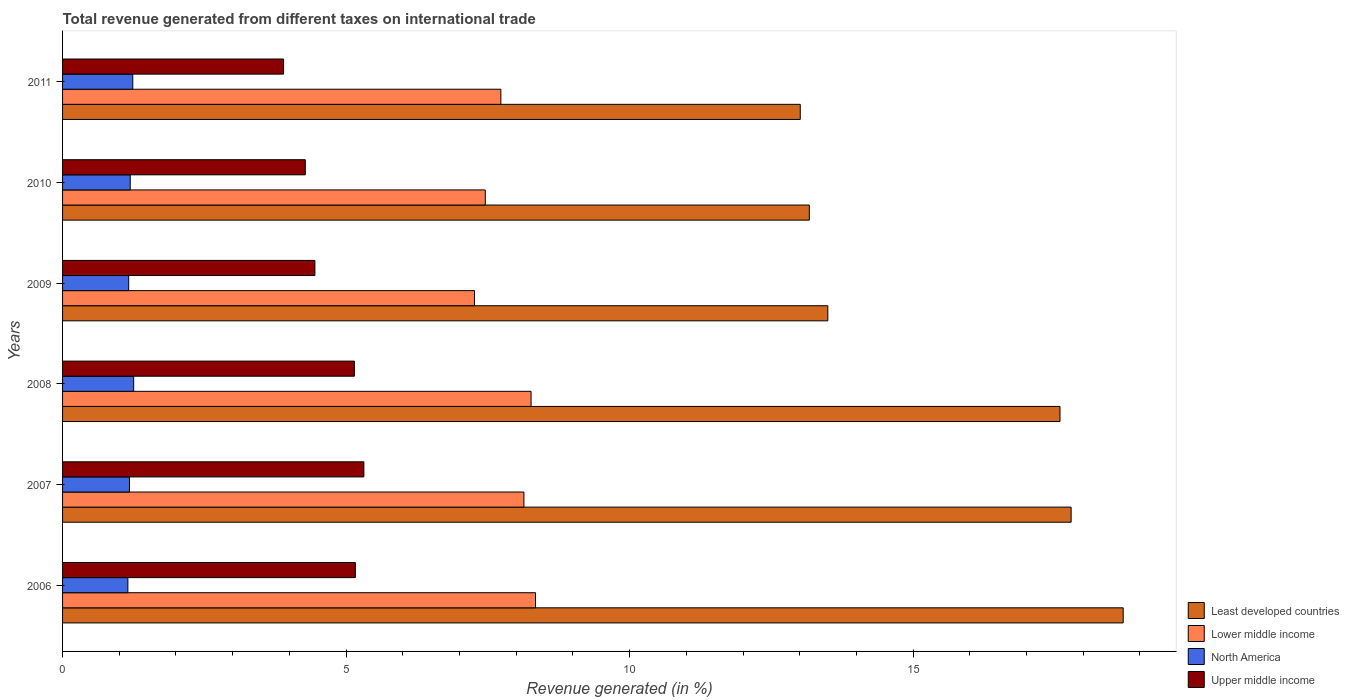How many groups of bars are there?
Make the answer very short. 6. Are the number of bars per tick equal to the number of legend labels?
Provide a succinct answer. Yes. How many bars are there on the 1st tick from the top?
Make the answer very short. 4. What is the total revenue generated in North America in 2011?
Provide a short and direct response. 1.24. Across all years, what is the maximum total revenue generated in Least developed countries?
Offer a terse response. 18.71. Across all years, what is the minimum total revenue generated in North America?
Make the answer very short. 1.15. In which year was the total revenue generated in Lower middle income minimum?
Keep it short and to the point. 2009. What is the total total revenue generated in North America in the graph?
Make the answer very short. 7.18. What is the difference between the total revenue generated in Upper middle income in 2007 and that in 2008?
Give a very brief answer. 0.17. What is the difference between the total revenue generated in Least developed countries in 2011 and the total revenue generated in North America in 2007?
Your answer should be compact. 11.83. What is the average total revenue generated in North America per year?
Make the answer very short. 1.2. In the year 2006, what is the difference between the total revenue generated in Upper middle income and total revenue generated in Lower middle income?
Give a very brief answer. -3.18. In how many years, is the total revenue generated in Lower middle income greater than 7 %?
Your answer should be compact. 6. What is the ratio of the total revenue generated in Lower middle income in 2008 to that in 2009?
Your answer should be very brief. 1.14. Is the difference between the total revenue generated in Upper middle income in 2009 and 2011 greater than the difference between the total revenue generated in Lower middle income in 2009 and 2011?
Offer a very short reply. Yes. What is the difference between the highest and the second highest total revenue generated in Least developed countries?
Keep it short and to the point. 0.92. What is the difference between the highest and the lowest total revenue generated in Upper middle income?
Your answer should be compact. 1.42. Is the sum of the total revenue generated in North America in 2008 and 2011 greater than the maximum total revenue generated in Lower middle income across all years?
Ensure brevity in your answer.  No. What does the 3rd bar from the top in 2009 represents?
Give a very brief answer. Lower middle income. What does the 4th bar from the bottom in 2008 represents?
Ensure brevity in your answer.  Upper middle income. How many bars are there?
Your response must be concise. 24. How many years are there in the graph?
Provide a short and direct response. 6. What is the difference between two consecutive major ticks on the X-axis?
Make the answer very short. 5. Does the graph contain any zero values?
Provide a succinct answer. No. How are the legend labels stacked?
Provide a succinct answer. Vertical. What is the title of the graph?
Make the answer very short. Total revenue generated from different taxes on international trade. What is the label or title of the X-axis?
Keep it short and to the point. Revenue generated (in %). What is the label or title of the Y-axis?
Your answer should be very brief. Years. What is the Revenue generated (in %) of Least developed countries in 2006?
Provide a succinct answer. 18.71. What is the Revenue generated (in %) in Lower middle income in 2006?
Offer a terse response. 8.34. What is the Revenue generated (in %) in North America in 2006?
Your answer should be very brief. 1.15. What is the Revenue generated (in %) of Upper middle income in 2006?
Ensure brevity in your answer.  5.16. What is the Revenue generated (in %) in Least developed countries in 2007?
Ensure brevity in your answer.  17.79. What is the Revenue generated (in %) in Lower middle income in 2007?
Give a very brief answer. 8.14. What is the Revenue generated (in %) of North America in 2007?
Your answer should be very brief. 1.18. What is the Revenue generated (in %) of Upper middle income in 2007?
Provide a succinct answer. 5.31. What is the Revenue generated (in %) of Least developed countries in 2008?
Offer a very short reply. 17.59. What is the Revenue generated (in %) in Lower middle income in 2008?
Provide a succinct answer. 8.26. What is the Revenue generated (in %) in North America in 2008?
Provide a short and direct response. 1.25. What is the Revenue generated (in %) of Upper middle income in 2008?
Your answer should be compact. 5.15. What is the Revenue generated (in %) in Least developed countries in 2009?
Offer a terse response. 13.5. What is the Revenue generated (in %) of Lower middle income in 2009?
Your answer should be compact. 7.26. What is the Revenue generated (in %) of North America in 2009?
Ensure brevity in your answer.  1.17. What is the Revenue generated (in %) of Upper middle income in 2009?
Your answer should be compact. 4.45. What is the Revenue generated (in %) in Least developed countries in 2010?
Keep it short and to the point. 13.17. What is the Revenue generated (in %) in Lower middle income in 2010?
Your answer should be compact. 7.45. What is the Revenue generated (in %) of North America in 2010?
Make the answer very short. 1.19. What is the Revenue generated (in %) in Upper middle income in 2010?
Keep it short and to the point. 4.28. What is the Revenue generated (in %) in Least developed countries in 2011?
Your answer should be compact. 13.01. What is the Revenue generated (in %) in Lower middle income in 2011?
Provide a short and direct response. 7.73. What is the Revenue generated (in %) of North America in 2011?
Your answer should be compact. 1.24. What is the Revenue generated (in %) in Upper middle income in 2011?
Make the answer very short. 3.9. Across all years, what is the maximum Revenue generated (in %) of Least developed countries?
Give a very brief answer. 18.71. Across all years, what is the maximum Revenue generated (in %) of Lower middle income?
Make the answer very short. 8.34. Across all years, what is the maximum Revenue generated (in %) of North America?
Give a very brief answer. 1.25. Across all years, what is the maximum Revenue generated (in %) of Upper middle income?
Keep it short and to the point. 5.31. Across all years, what is the minimum Revenue generated (in %) in Least developed countries?
Provide a short and direct response. 13.01. Across all years, what is the minimum Revenue generated (in %) of Lower middle income?
Offer a terse response. 7.26. Across all years, what is the minimum Revenue generated (in %) in North America?
Ensure brevity in your answer.  1.15. Across all years, what is the minimum Revenue generated (in %) in Upper middle income?
Your answer should be very brief. 3.9. What is the total Revenue generated (in %) in Least developed countries in the graph?
Your answer should be compact. 93.76. What is the total Revenue generated (in %) of Lower middle income in the graph?
Make the answer very short. 47.19. What is the total Revenue generated (in %) in North America in the graph?
Offer a very short reply. 7.18. What is the total Revenue generated (in %) of Upper middle income in the graph?
Your answer should be compact. 28.25. What is the difference between the Revenue generated (in %) of Least developed countries in 2006 and that in 2007?
Provide a succinct answer. 0.92. What is the difference between the Revenue generated (in %) in Lower middle income in 2006 and that in 2007?
Ensure brevity in your answer.  0.2. What is the difference between the Revenue generated (in %) of North America in 2006 and that in 2007?
Keep it short and to the point. -0.03. What is the difference between the Revenue generated (in %) in Least developed countries in 2006 and that in 2008?
Make the answer very short. 1.11. What is the difference between the Revenue generated (in %) of Lower middle income in 2006 and that in 2008?
Your answer should be compact. 0.08. What is the difference between the Revenue generated (in %) of North America in 2006 and that in 2008?
Keep it short and to the point. -0.1. What is the difference between the Revenue generated (in %) of Upper middle income in 2006 and that in 2008?
Give a very brief answer. 0.02. What is the difference between the Revenue generated (in %) of Least developed countries in 2006 and that in 2009?
Your response must be concise. 5.21. What is the difference between the Revenue generated (in %) in Lower middle income in 2006 and that in 2009?
Provide a succinct answer. 1.08. What is the difference between the Revenue generated (in %) of North America in 2006 and that in 2009?
Make the answer very short. -0.01. What is the difference between the Revenue generated (in %) in Upper middle income in 2006 and that in 2009?
Give a very brief answer. 0.71. What is the difference between the Revenue generated (in %) of Least developed countries in 2006 and that in 2010?
Offer a terse response. 5.54. What is the difference between the Revenue generated (in %) of Lower middle income in 2006 and that in 2010?
Provide a succinct answer. 0.89. What is the difference between the Revenue generated (in %) of North America in 2006 and that in 2010?
Give a very brief answer. -0.04. What is the difference between the Revenue generated (in %) of Upper middle income in 2006 and that in 2010?
Make the answer very short. 0.88. What is the difference between the Revenue generated (in %) in Least developed countries in 2006 and that in 2011?
Keep it short and to the point. 5.7. What is the difference between the Revenue generated (in %) of Lower middle income in 2006 and that in 2011?
Provide a short and direct response. 0.61. What is the difference between the Revenue generated (in %) in North America in 2006 and that in 2011?
Your response must be concise. -0.09. What is the difference between the Revenue generated (in %) in Upper middle income in 2006 and that in 2011?
Provide a succinct answer. 1.27. What is the difference between the Revenue generated (in %) of Least developed countries in 2007 and that in 2008?
Your answer should be compact. 0.2. What is the difference between the Revenue generated (in %) in Lower middle income in 2007 and that in 2008?
Your answer should be very brief. -0.13. What is the difference between the Revenue generated (in %) of North America in 2007 and that in 2008?
Provide a short and direct response. -0.07. What is the difference between the Revenue generated (in %) of Upper middle income in 2007 and that in 2008?
Provide a short and direct response. 0.17. What is the difference between the Revenue generated (in %) in Least developed countries in 2007 and that in 2009?
Give a very brief answer. 4.29. What is the difference between the Revenue generated (in %) of Lower middle income in 2007 and that in 2009?
Keep it short and to the point. 0.87. What is the difference between the Revenue generated (in %) in North America in 2007 and that in 2009?
Give a very brief answer. 0.01. What is the difference between the Revenue generated (in %) in Upper middle income in 2007 and that in 2009?
Provide a succinct answer. 0.86. What is the difference between the Revenue generated (in %) of Least developed countries in 2007 and that in 2010?
Provide a succinct answer. 4.62. What is the difference between the Revenue generated (in %) of Lower middle income in 2007 and that in 2010?
Provide a short and direct response. 0.68. What is the difference between the Revenue generated (in %) in North America in 2007 and that in 2010?
Offer a very short reply. -0.01. What is the difference between the Revenue generated (in %) in Upper middle income in 2007 and that in 2010?
Provide a short and direct response. 1.03. What is the difference between the Revenue generated (in %) of Least developed countries in 2007 and that in 2011?
Provide a short and direct response. 4.78. What is the difference between the Revenue generated (in %) in Lower middle income in 2007 and that in 2011?
Provide a short and direct response. 0.41. What is the difference between the Revenue generated (in %) in North America in 2007 and that in 2011?
Provide a succinct answer. -0.06. What is the difference between the Revenue generated (in %) in Upper middle income in 2007 and that in 2011?
Your answer should be compact. 1.42. What is the difference between the Revenue generated (in %) in Least developed countries in 2008 and that in 2009?
Your response must be concise. 4.09. What is the difference between the Revenue generated (in %) of Lower middle income in 2008 and that in 2009?
Your answer should be very brief. 1. What is the difference between the Revenue generated (in %) in North America in 2008 and that in 2009?
Make the answer very short. 0.09. What is the difference between the Revenue generated (in %) in Upper middle income in 2008 and that in 2009?
Provide a short and direct response. 0.7. What is the difference between the Revenue generated (in %) in Least developed countries in 2008 and that in 2010?
Offer a terse response. 4.42. What is the difference between the Revenue generated (in %) in Lower middle income in 2008 and that in 2010?
Offer a very short reply. 0.81. What is the difference between the Revenue generated (in %) of North America in 2008 and that in 2010?
Your answer should be very brief. 0.06. What is the difference between the Revenue generated (in %) in Upper middle income in 2008 and that in 2010?
Give a very brief answer. 0.87. What is the difference between the Revenue generated (in %) of Least developed countries in 2008 and that in 2011?
Your answer should be very brief. 4.58. What is the difference between the Revenue generated (in %) in Lower middle income in 2008 and that in 2011?
Ensure brevity in your answer.  0.53. What is the difference between the Revenue generated (in %) of North America in 2008 and that in 2011?
Ensure brevity in your answer.  0.02. What is the difference between the Revenue generated (in %) of Upper middle income in 2008 and that in 2011?
Make the answer very short. 1.25. What is the difference between the Revenue generated (in %) in Least developed countries in 2009 and that in 2010?
Your answer should be compact. 0.33. What is the difference between the Revenue generated (in %) of Lower middle income in 2009 and that in 2010?
Keep it short and to the point. -0.19. What is the difference between the Revenue generated (in %) of North America in 2009 and that in 2010?
Your answer should be compact. -0.03. What is the difference between the Revenue generated (in %) of Upper middle income in 2009 and that in 2010?
Offer a terse response. 0.17. What is the difference between the Revenue generated (in %) of Least developed countries in 2009 and that in 2011?
Provide a succinct answer. 0.49. What is the difference between the Revenue generated (in %) in Lower middle income in 2009 and that in 2011?
Provide a short and direct response. -0.47. What is the difference between the Revenue generated (in %) of North America in 2009 and that in 2011?
Keep it short and to the point. -0.07. What is the difference between the Revenue generated (in %) in Upper middle income in 2009 and that in 2011?
Provide a succinct answer. 0.55. What is the difference between the Revenue generated (in %) in Least developed countries in 2010 and that in 2011?
Provide a succinct answer. 0.16. What is the difference between the Revenue generated (in %) in Lower middle income in 2010 and that in 2011?
Your response must be concise. -0.27. What is the difference between the Revenue generated (in %) in North America in 2010 and that in 2011?
Give a very brief answer. -0.04. What is the difference between the Revenue generated (in %) in Upper middle income in 2010 and that in 2011?
Offer a very short reply. 0.38. What is the difference between the Revenue generated (in %) of Least developed countries in 2006 and the Revenue generated (in %) of Lower middle income in 2007?
Provide a short and direct response. 10.57. What is the difference between the Revenue generated (in %) of Least developed countries in 2006 and the Revenue generated (in %) of North America in 2007?
Your response must be concise. 17.53. What is the difference between the Revenue generated (in %) in Least developed countries in 2006 and the Revenue generated (in %) in Upper middle income in 2007?
Offer a terse response. 13.39. What is the difference between the Revenue generated (in %) in Lower middle income in 2006 and the Revenue generated (in %) in North America in 2007?
Offer a very short reply. 7.16. What is the difference between the Revenue generated (in %) of Lower middle income in 2006 and the Revenue generated (in %) of Upper middle income in 2007?
Provide a succinct answer. 3.03. What is the difference between the Revenue generated (in %) in North America in 2006 and the Revenue generated (in %) in Upper middle income in 2007?
Your answer should be very brief. -4.16. What is the difference between the Revenue generated (in %) in Least developed countries in 2006 and the Revenue generated (in %) in Lower middle income in 2008?
Ensure brevity in your answer.  10.44. What is the difference between the Revenue generated (in %) of Least developed countries in 2006 and the Revenue generated (in %) of North America in 2008?
Your answer should be very brief. 17.45. What is the difference between the Revenue generated (in %) in Least developed countries in 2006 and the Revenue generated (in %) in Upper middle income in 2008?
Your response must be concise. 13.56. What is the difference between the Revenue generated (in %) in Lower middle income in 2006 and the Revenue generated (in %) in North America in 2008?
Your answer should be very brief. 7.09. What is the difference between the Revenue generated (in %) in Lower middle income in 2006 and the Revenue generated (in %) in Upper middle income in 2008?
Provide a succinct answer. 3.19. What is the difference between the Revenue generated (in %) in North America in 2006 and the Revenue generated (in %) in Upper middle income in 2008?
Provide a succinct answer. -3.99. What is the difference between the Revenue generated (in %) of Least developed countries in 2006 and the Revenue generated (in %) of Lower middle income in 2009?
Give a very brief answer. 11.44. What is the difference between the Revenue generated (in %) of Least developed countries in 2006 and the Revenue generated (in %) of North America in 2009?
Provide a short and direct response. 17.54. What is the difference between the Revenue generated (in %) in Least developed countries in 2006 and the Revenue generated (in %) in Upper middle income in 2009?
Ensure brevity in your answer.  14.26. What is the difference between the Revenue generated (in %) in Lower middle income in 2006 and the Revenue generated (in %) in North America in 2009?
Your answer should be compact. 7.18. What is the difference between the Revenue generated (in %) in Lower middle income in 2006 and the Revenue generated (in %) in Upper middle income in 2009?
Give a very brief answer. 3.89. What is the difference between the Revenue generated (in %) of North America in 2006 and the Revenue generated (in %) of Upper middle income in 2009?
Make the answer very short. -3.3. What is the difference between the Revenue generated (in %) in Least developed countries in 2006 and the Revenue generated (in %) in Lower middle income in 2010?
Your answer should be very brief. 11.25. What is the difference between the Revenue generated (in %) of Least developed countries in 2006 and the Revenue generated (in %) of North America in 2010?
Your answer should be very brief. 17.51. What is the difference between the Revenue generated (in %) of Least developed countries in 2006 and the Revenue generated (in %) of Upper middle income in 2010?
Provide a succinct answer. 14.42. What is the difference between the Revenue generated (in %) of Lower middle income in 2006 and the Revenue generated (in %) of North America in 2010?
Provide a succinct answer. 7.15. What is the difference between the Revenue generated (in %) of Lower middle income in 2006 and the Revenue generated (in %) of Upper middle income in 2010?
Offer a very short reply. 4.06. What is the difference between the Revenue generated (in %) of North America in 2006 and the Revenue generated (in %) of Upper middle income in 2010?
Your answer should be compact. -3.13. What is the difference between the Revenue generated (in %) of Least developed countries in 2006 and the Revenue generated (in %) of Lower middle income in 2011?
Offer a very short reply. 10.98. What is the difference between the Revenue generated (in %) in Least developed countries in 2006 and the Revenue generated (in %) in North America in 2011?
Ensure brevity in your answer.  17.47. What is the difference between the Revenue generated (in %) of Least developed countries in 2006 and the Revenue generated (in %) of Upper middle income in 2011?
Offer a very short reply. 14.81. What is the difference between the Revenue generated (in %) in Lower middle income in 2006 and the Revenue generated (in %) in North America in 2011?
Offer a very short reply. 7.1. What is the difference between the Revenue generated (in %) in Lower middle income in 2006 and the Revenue generated (in %) in Upper middle income in 2011?
Provide a short and direct response. 4.44. What is the difference between the Revenue generated (in %) of North America in 2006 and the Revenue generated (in %) of Upper middle income in 2011?
Provide a short and direct response. -2.75. What is the difference between the Revenue generated (in %) in Least developed countries in 2007 and the Revenue generated (in %) in Lower middle income in 2008?
Your answer should be compact. 9.52. What is the difference between the Revenue generated (in %) in Least developed countries in 2007 and the Revenue generated (in %) in North America in 2008?
Give a very brief answer. 16.53. What is the difference between the Revenue generated (in %) in Least developed countries in 2007 and the Revenue generated (in %) in Upper middle income in 2008?
Ensure brevity in your answer.  12.64. What is the difference between the Revenue generated (in %) in Lower middle income in 2007 and the Revenue generated (in %) in North America in 2008?
Your answer should be very brief. 6.88. What is the difference between the Revenue generated (in %) of Lower middle income in 2007 and the Revenue generated (in %) of Upper middle income in 2008?
Provide a short and direct response. 2.99. What is the difference between the Revenue generated (in %) of North America in 2007 and the Revenue generated (in %) of Upper middle income in 2008?
Keep it short and to the point. -3.97. What is the difference between the Revenue generated (in %) of Least developed countries in 2007 and the Revenue generated (in %) of Lower middle income in 2009?
Your answer should be compact. 10.52. What is the difference between the Revenue generated (in %) of Least developed countries in 2007 and the Revenue generated (in %) of North America in 2009?
Offer a very short reply. 16.62. What is the difference between the Revenue generated (in %) in Least developed countries in 2007 and the Revenue generated (in %) in Upper middle income in 2009?
Offer a very short reply. 13.34. What is the difference between the Revenue generated (in %) of Lower middle income in 2007 and the Revenue generated (in %) of North America in 2009?
Provide a short and direct response. 6.97. What is the difference between the Revenue generated (in %) in Lower middle income in 2007 and the Revenue generated (in %) in Upper middle income in 2009?
Provide a short and direct response. 3.69. What is the difference between the Revenue generated (in %) of North America in 2007 and the Revenue generated (in %) of Upper middle income in 2009?
Make the answer very short. -3.27. What is the difference between the Revenue generated (in %) in Least developed countries in 2007 and the Revenue generated (in %) in Lower middle income in 2010?
Your answer should be very brief. 10.33. What is the difference between the Revenue generated (in %) of Least developed countries in 2007 and the Revenue generated (in %) of North America in 2010?
Your answer should be very brief. 16.59. What is the difference between the Revenue generated (in %) of Least developed countries in 2007 and the Revenue generated (in %) of Upper middle income in 2010?
Offer a very short reply. 13.51. What is the difference between the Revenue generated (in %) of Lower middle income in 2007 and the Revenue generated (in %) of North America in 2010?
Your answer should be very brief. 6.94. What is the difference between the Revenue generated (in %) of Lower middle income in 2007 and the Revenue generated (in %) of Upper middle income in 2010?
Give a very brief answer. 3.86. What is the difference between the Revenue generated (in %) of North America in 2007 and the Revenue generated (in %) of Upper middle income in 2010?
Make the answer very short. -3.1. What is the difference between the Revenue generated (in %) in Least developed countries in 2007 and the Revenue generated (in %) in Lower middle income in 2011?
Ensure brevity in your answer.  10.06. What is the difference between the Revenue generated (in %) in Least developed countries in 2007 and the Revenue generated (in %) in North America in 2011?
Offer a very short reply. 16.55. What is the difference between the Revenue generated (in %) in Least developed countries in 2007 and the Revenue generated (in %) in Upper middle income in 2011?
Your answer should be compact. 13.89. What is the difference between the Revenue generated (in %) of Lower middle income in 2007 and the Revenue generated (in %) of North America in 2011?
Offer a terse response. 6.9. What is the difference between the Revenue generated (in %) in Lower middle income in 2007 and the Revenue generated (in %) in Upper middle income in 2011?
Offer a terse response. 4.24. What is the difference between the Revenue generated (in %) in North America in 2007 and the Revenue generated (in %) in Upper middle income in 2011?
Your response must be concise. -2.72. What is the difference between the Revenue generated (in %) in Least developed countries in 2008 and the Revenue generated (in %) in Lower middle income in 2009?
Offer a very short reply. 10.33. What is the difference between the Revenue generated (in %) in Least developed countries in 2008 and the Revenue generated (in %) in North America in 2009?
Keep it short and to the point. 16.43. What is the difference between the Revenue generated (in %) of Least developed countries in 2008 and the Revenue generated (in %) of Upper middle income in 2009?
Give a very brief answer. 13.14. What is the difference between the Revenue generated (in %) in Lower middle income in 2008 and the Revenue generated (in %) in North America in 2009?
Your response must be concise. 7.1. What is the difference between the Revenue generated (in %) of Lower middle income in 2008 and the Revenue generated (in %) of Upper middle income in 2009?
Your answer should be very brief. 3.81. What is the difference between the Revenue generated (in %) of North America in 2008 and the Revenue generated (in %) of Upper middle income in 2009?
Make the answer very short. -3.2. What is the difference between the Revenue generated (in %) of Least developed countries in 2008 and the Revenue generated (in %) of Lower middle income in 2010?
Keep it short and to the point. 10.14. What is the difference between the Revenue generated (in %) of Least developed countries in 2008 and the Revenue generated (in %) of North America in 2010?
Give a very brief answer. 16.4. What is the difference between the Revenue generated (in %) of Least developed countries in 2008 and the Revenue generated (in %) of Upper middle income in 2010?
Provide a short and direct response. 13.31. What is the difference between the Revenue generated (in %) of Lower middle income in 2008 and the Revenue generated (in %) of North America in 2010?
Give a very brief answer. 7.07. What is the difference between the Revenue generated (in %) in Lower middle income in 2008 and the Revenue generated (in %) in Upper middle income in 2010?
Your response must be concise. 3.98. What is the difference between the Revenue generated (in %) of North America in 2008 and the Revenue generated (in %) of Upper middle income in 2010?
Your answer should be very brief. -3.03. What is the difference between the Revenue generated (in %) in Least developed countries in 2008 and the Revenue generated (in %) in Lower middle income in 2011?
Provide a succinct answer. 9.86. What is the difference between the Revenue generated (in %) in Least developed countries in 2008 and the Revenue generated (in %) in North America in 2011?
Make the answer very short. 16.35. What is the difference between the Revenue generated (in %) in Least developed countries in 2008 and the Revenue generated (in %) in Upper middle income in 2011?
Your answer should be very brief. 13.69. What is the difference between the Revenue generated (in %) of Lower middle income in 2008 and the Revenue generated (in %) of North America in 2011?
Ensure brevity in your answer.  7.02. What is the difference between the Revenue generated (in %) in Lower middle income in 2008 and the Revenue generated (in %) in Upper middle income in 2011?
Offer a very short reply. 4.36. What is the difference between the Revenue generated (in %) of North America in 2008 and the Revenue generated (in %) of Upper middle income in 2011?
Provide a succinct answer. -2.64. What is the difference between the Revenue generated (in %) in Least developed countries in 2009 and the Revenue generated (in %) in Lower middle income in 2010?
Keep it short and to the point. 6.04. What is the difference between the Revenue generated (in %) in Least developed countries in 2009 and the Revenue generated (in %) in North America in 2010?
Keep it short and to the point. 12.3. What is the difference between the Revenue generated (in %) in Least developed countries in 2009 and the Revenue generated (in %) in Upper middle income in 2010?
Keep it short and to the point. 9.21. What is the difference between the Revenue generated (in %) in Lower middle income in 2009 and the Revenue generated (in %) in North America in 2010?
Provide a short and direct response. 6.07. What is the difference between the Revenue generated (in %) of Lower middle income in 2009 and the Revenue generated (in %) of Upper middle income in 2010?
Keep it short and to the point. 2.98. What is the difference between the Revenue generated (in %) in North America in 2009 and the Revenue generated (in %) in Upper middle income in 2010?
Provide a succinct answer. -3.12. What is the difference between the Revenue generated (in %) in Least developed countries in 2009 and the Revenue generated (in %) in Lower middle income in 2011?
Keep it short and to the point. 5.77. What is the difference between the Revenue generated (in %) of Least developed countries in 2009 and the Revenue generated (in %) of North America in 2011?
Your answer should be compact. 12.26. What is the difference between the Revenue generated (in %) of Least developed countries in 2009 and the Revenue generated (in %) of Upper middle income in 2011?
Make the answer very short. 9.6. What is the difference between the Revenue generated (in %) in Lower middle income in 2009 and the Revenue generated (in %) in North America in 2011?
Your response must be concise. 6.03. What is the difference between the Revenue generated (in %) in Lower middle income in 2009 and the Revenue generated (in %) in Upper middle income in 2011?
Offer a terse response. 3.37. What is the difference between the Revenue generated (in %) in North America in 2009 and the Revenue generated (in %) in Upper middle income in 2011?
Give a very brief answer. -2.73. What is the difference between the Revenue generated (in %) in Least developed countries in 2010 and the Revenue generated (in %) in Lower middle income in 2011?
Your answer should be very brief. 5.44. What is the difference between the Revenue generated (in %) in Least developed countries in 2010 and the Revenue generated (in %) in North America in 2011?
Offer a very short reply. 11.93. What is the difference between the Revenue generated (in %) in Least developed countries in 2010 and the Revenue generated (in %) in Upper middle income in 2011?
Give a very brief answer. 9.27. What is the difference between the Revenue generated (in %) in Lower middle income in 2010 and the Revenue generated (in %) in North America in 2011?
Your answer should be compact. 6.22. What is the difference between the Revenue generated (in %) in Lower middle income in 2010 and the Revenue generated (in %) in Upper middle income in 2011?
Keep it short and to the point. 3.56. What is the difference between the Revenue generated (in %) of North America in 2010 and the Revenue generated (in %) of Upper middle income in 2011?
Offer a very short reply. -2.7. What is the average Revenue generated (in %) of Least developed countries per year?
Ensure brevity in your answer.  15.63. What is the average Revenue generated (in %) in Lower middle income per year?
Make the answer very short. 7.86. What is the average Revenue generated (in %) of North America per year?
Provide a short and direct response. 1.2. What is the average Revenue generated (in %) of Upper middle income per year?
Your answer should be very brief. 4.71. In the year 2006, what is the difference between the Revenue generated (in %) of Least developed countries and Revenue generated (in %) of Lower middle income?
Provide a short and direct response. 10.36. In the year 2006, what is the difference between the Revenue generated (in %) in Least developed countries and Revenue generated (in %) in North America?
Your answer should be compact. 17.55. In the year 2006, what is the difference between the Revenue generated (in %) in Least developed countries and Revenue generated (in %) in Upper middle income?
Give a very brief answer. 13.54. In the year 2006, what is the difference between the Revenue generated (in %) of Lower middle income and Revenue generated (in %) of North America?
Offer a terse response. 7.19. In the year 2006, what is the difference between the Revenue generated (in %) in Lower middle income and Revenue generated (in %) in Upper middle income?
Offer a terse response. 3.18. In the year 2006, what is the difference between the Revenue generated (in %) of North America and Revenue generated (in %) of Upper middle income?
Provide a succinct answer. -4.01. In the year 2007, what is the difference between the Revenue generated (in %) in Least developed countries and Revenue generated (in %) in Lower middle income?
Your answer should be very brief. 9.65. In the year 2007, what is the difference between the Revenue generated (in %) of Least developed countries and Revenue generated (in %) of North America?
Provide a short and direct response. 16.61. In the year 2007, what is the difference between the Revenue generated (in %) of Least developed countries and Revenue generated (in %) of Upper middle income?
Provide a short and direct response. 12.47. In the year 2007, what is the difference between the Revenue generated (in %) in Lower middle income and Revenue generated (in %) in North America?
Provide a succinct answer. 6.96. In the year 2007, what is the difference between the Revenue generated (in %) in Lower middle income and Revenue generated (in %) in Upper middle income?
Make the answer very short. 2.82. In the year 2007, what is the difference between the Revenue generated (in %) of North America and Revenue generated (in %) of Upper middle income?
Provide a short and direct response. -4.13. In the year 2008, what is the difference between the Revenue generated (in %) in Least developed countries and Revenue generated (in %) in Lower middle income?
Ensure brevity in your answer.  9.33. In the year 2008, what is the difference between the Revenue generated (in %) of Least developed countries and Revenue generated (in %) of North America?
Offer a terse response. 16.34. In the year 2008, what is the difference between the Revenue generated (in %) of Least developed countries and Revenue generated (in %) of Upper middle income?
Make the answer very short. 12.44. In the year 2008, what is the difference between the Revenue generated (in %) in Lower middle income and Revenue generated (in %) in North America?
Offer a very short reply. 7.01. In the year 2008, what is the difference between the Revenue generated (in %) of Lower middle income and Revenue generated (in %) of Upper middle income?
Give a very brief answer. 3.12. In the year 2008, what is the difference between the Revenue generated (in %) of North America and Revenue generated (in %) of Upper middle income?
Ensure brevity in your answer.  -3.89. In the year 2009, what is the difference between the Revenue generated (in %) of Least developed countries and Revenue generated (in %) of Lower middle income?
Offer a very short reply. 6.23. In the year 2009, what is the difference between the Revenue generated (in %) of Least developed countries and Revenue generated (in %) of North America?
Ensure brevity in your answer.  12.33. In the year 2009, what is the difference between the Revenue generated (in %) in Least developed countries and Revenue generated (in %) in Upper middle income?
Ensure brevity in your answer.  9.05. In the year 2009, what is the difference between the Revenue generated (in %) of Lower middle income and Revenue generated (in %) of North America?
Give a very brief answer. 6.1. In the year 2009, what is the difference between the Revenue generated (in %) in Lower middle income and Revenue generated (in %) in Upper middle income?
Provide a succinct answer. 2.81. In the year 2009, what is the difference between the Revenue generated (in %) in North America and Revenue generated (in %) in Upper middle income?
Provide a short and direct response. -3.28. In the year 2010, what is the difference between the Revenue generated (in %) in Least developed countries and Revenue generated (in %) in Lower middle income?
Provide a short and direct response. 5.71. In the year 2010, what is the difference between the Revenue generated (in %) in Least developed countries and Revenue generated (in %) in North America?
Give a very brief answer. 11.98. In the year 2010, what is the difference between the Revenue generated (in %) of Least developed countries and Revenue generated (in %) of Upper middle income?
Ensure brevity in your answer.  8.89. In the year 2010, what is the difference between the Revenue generated (in %) in Lower middle income and Revenue generated (in %) in North America?
Provide a short and direct response. 6.26. In the year 2010, what is the difference between the Revenue generated (in %) in Lower middle income and Revenue generated (in %) in Upper middle income?
Keep it short and to the point. 3.17. In the year 2010, what is the difference between the Revenue generated (in %) of North America and Revenue generated (in %) of Upper middle income?
Your response must be concise. -3.09. In the year 2011, what is the difference between the Revenue generated (in %) of Least developed countries and Revenue generated (in %) of Lower middle income?
Provide a succinct answer. 5.28. In the year 2011, what is the difference between the Revenue generated (in %) of Least developed countries and Revenue generated (in %) of North America?
Offer a terse response. 11.77. In the year 2011, what is the difference between the Revenue generated (in %) in Least developed countries and Revenue generated (in %) in Upper middle income?
Provide a succinct answer. 9.11. In the year 2011, what is the difference between the Revenue generated (in %) of Lower middle income and Revenue generated (in %) of North America?
Your response must be concise. 6.49. In the year 2011, what is the difference between the Revenue generated (in %) in Lower middle income and Revenue generated (in %) in Upper middle income?
Offer a terse response. 3.83. In the year 2011, what is the difference between the Revenue generated (in %) of North America and Revenue generated (in %) of Upper middle income?
Your answer should be very brief. -2.66. What is the ratio of the Revenue generated (in %) in Least developed countries in 2006 to that in 2007?
Make the answer very short. 1.05. What is the ratio of the Revenue generated (in %) in Lower middle income in 2006 to that in 2007?
Your response must be concise. 1.03. What is the ratio of the Revenue generated (in %) in North America in 2006 to that in 2007?
Your answer should be very brief. 0.98. What is the ratio of the Revenue generated (in %) in Upper middle income in 2006 to that in 2007?
Give a very brief answer. 0.97. What is the ratio of the Revenue generated (in %) of Least developed countries in 2006 to that in 2008?
Give a very brief answer. 1.06. What is the ratio of the Revenue generated (in %) of Lower middle income in 2006 to that in 2008?
Keep it short and to the point. 1.01. What is the ratio of the Revenue generated (in %) in North America in 2006 to that in 2008?
Provide a succinct answer. 0.92. What is the ratio of the Revenue generated (in %) in Upper middle income in 2006 to that in 2008?
Your answer should be compact. 1. What is the ratio of the Revenue generated (in %) in Least developed countries in 2006 to that in 2009?
Provide a succinct answer. 1.39. What is the ratio of the Revenue generated (in %) of Lower middle income in 2006 to that in 2009?
Offer a very short reply. 1.15. What is the ratio of the Revenue generated (in %) of North America in 2006 to that in 2009?
Keep it short and to the point. 0.99. What is the ratio of the Revenue generated (in %) of Upper middle income in 2006 to that in 2009?
Your answer should be compact. 1.16. What is the ratio of the Revenue generated (in %) of Least developed countries in 2006 to that in 2010?
Keep it short and to the point. 1.42. What is the ratio of the Revenue generated (in %) of Lower middle income in 2006 to that in 2010?
Your answer should be compact. 1.12. What is the ratio of the Revenue generated (in %) in North America in 2006 to that in 2010?
Give a very brief answer. 0.97. What is the ratio of the Revenue generated (in %) in Upper middle income in 2006 to that in 2010?
Ensure brevity in your answer.  1.21. What is the ratio of the Revenue generated (in %) of Least developed countries in 2006 to that in 2011?
Offer a terse response. 1.44. What is the ratio of the Revenue generated (in %) in Lower middle income in 2006 to that in 2011?
Ensure brevity in your answer.  1.08. What is the ratio of the Revenue generated (in %) in North America in 2006 to that in 2011?
Offer a very short reply. 0.93. What is the ratio of the Revenue generated (in %) in Upper middle income in 2006 to that in 2011?
Your answer should be compact. 1.32. What is the ratio of the Revenue generated (in %) in Least developed countries in 2007 to that in 2008?
Provide a short and direct response. 1.01. What is the ratio of the Revenue generated (in %) of Lower middle income in 2007 to that in 2008?
Your answer should be compact. 0.98. What is the ratio of the Revenue generated (in %) in North America in 2007 to that in 2008?
Ensure brevity in your answer.  0.94. What is the ratio of the Revenue generated (in %) in Upper middle income in 2007 to that in 2008?
Your answer should be very brief. 1.03. What is the ratio of the Revenue generated (in %) of Least developed countries in 2007 to that in 2009?
Provide a short and direct response. 1.32. What is the ratio of the Revenue generated (in %) of Lower middle income in 2007 to that in 2009?
Give a very brief answer. 1.12. What is the ratio of the Revenue generated (in %) in North America in 2007 to that in 2009?
Provide a succinct answer. 1.01. What is the ratio of the Revenue generated (in %) in Upper middle income in 2007 to that in 2009?
Provide a succinct answer. 1.19. What is the ratio of the Revenue generated (in %) of Least developed countries in 2007 to that in 2010?
Your response must be concise. 1.35. What is the ratio of the Revenue generated (in %) in Lower middle income in 2007 to that in 2010?
Offer a terse response. 1.09. What is the ratio of the Revenue generated (in %) in Upper middle income in 2007 to that in 2010?
Offer a terse response. 1.24. What is the ratio of the Revenue generated (in %) in Least developed countries in 2007 to that in 2011?
Provide a succinct answer. 1.37. What is the ratio of the Revenue generated (in %) in Lower middle income in 2007 to that in 2011?
Provide a succinct answer. 1.05. What is the ratio of the Revenue generated (in %) of North America in 2007 to that in 2011?
Your answer should be very brief. 0.95. What is the ratio of the Revenue generated (in %) in Upper middle income in 2007 to that in 2011?
Ensure brevity in your answer.  1.36. What is the ratio of the Revenue generated (in %) in Least developed countries in 2008 to that in 2009?
Your response must be concise. 1.3. What is the ratio of the Revenue generated (in %) in Lower middle income in 2008 to that in 2009?
Provide a short and direct response. 1.14. What is the ratio of the Revenue generated (in %) in North America in 2008 to that in 2009?
Provide a succinct answer. 1.08. What is the ratio of the Revenue generated (in %) in Upper middle income in 2008 to that in 2009?
Ensure brevity in your answer.  1.16. What is the ratio of the Revenue generated (in %) of Least developed countries in 2008 to that in 2010?
Make the answer very short. 1.34. What is the ratio of the Revenue generated (in %) in Lower middle income in 2008 to that in 2010?
Your answer should be compact. 1.11. What is the ratio of the Revenue generated (in %) in North America in 2008 to that in 2010?
Keep it short and to the point. 1.05. What is the ratio of the Revenue generated (in %) in Upper middle income in 2008 to that in 2010?
Offer a very short reply. 1.2. What is the ratio of the Revenue generated (in %) of Least developed countries in 2008 to that in 2011?
Ensure brevity in your answer.  1.35. What is the ratio of the Revenue generated (in %) in Lower middle income in 2008 to that in 2011?
Your answer should be compact. 1.07. What is the ratio of the Revenue generated (in %) of North America in 2008 to that in 2011?
Provide a short and direct response. 1.01. What is the ratio of the Revenue generated (in %) in Upper middle income in 2008 to that in 2011?
Your answer should be very brief. 1.32. What is the ratio of the Revenue generated (in %) of Least developed countries in 2009 to that in 2010?
Provide a succinct answer. 1.02. What is the ratio of the Revenue generated (in %) of Lower middle income in 2009 to that in 2010?
Your answer should be very brief. 0.97. What is the ratio of the Revenue generated (in %) in North America in 2009 to that in 2010?
Ensure brevity in your answer.  0.98. What is the ratio of the Revenue generated (in %) in Upper middle income in 2009 to that in 2010?
Provide a short and direct response. 1.04. What is the ratio of the Revenue generated (in %) in Least developed countries in 2009 to that in 2011?
Keep it short and to the point. 1.04. What is the ratio of the Revenue generated (in %) of Lower middle income in 2009 to that in 2011?
Your answer should be compact. 0.94. What is the ratio of the Revenue generated (in %) of North America in 2009 to that in 2011?
Offer a terse response. 0.94. What is the ratio of the Revenue generated (in %) in Upper middle income in 2009 to that in 2011?
Your answer should be compact. 1.14. What is the ratio of the Revenue generated (in %) in Least developed countries in 2010 to that in 2011?
Make the answer very short. 1.01. What is the ratio of the Revenue generated (in %) of Lower middle income in 2010 to that in 2011?
Offer a terse response. 0.96. What is the ratio of the Revenue generated (in %) of North America in 2010 to that in 2011?
Your answer should be very brief. 0.96. What is the ratio of the Revenue generated (in %) in Upper middle income in 2010 to that in 2011?
Provide a succinct answer. 1.1. What is the difference between the highest and the second highest Revenue generated (in %) in Least developed countries?
Your answer should be very brief. 0.92. What is the difference between the highest and the second highest Revenue generated (in %) in Lower middle income?
Your response must be concise. 0.08. What is the difference between the highest and the second highest Revenue generated (in %) of North America?
Keep it short and to the point. 0.02. What is the difference between the highest and the second highest Revenue generated (in %) of Upper middle income?
Ensure brevity in your answer.  0.15. What is the difference between the highest and the lowest Revenue generated (in %) in Least developed countries?
Your response must be concise. 5.7. What is the difference between the highest and the lowest Revenue generated (in %) in Lower middle income?
Your answer should be very brief. 1.08. What is the difference between the highest and the lowest Revenue generated (in %) in North America?
Offer a terse response. 0.1. What is the difference between the highest and the lowest Revenue generated (in %) of Upper middle income?
Offer a very short reply. 1.42. 